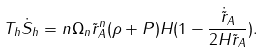Convert formula to latex. <formula><loc_0><loc_0><loc_500><loc_500>T _ { h } \dot { S } _ { h } = n \Omega _ { n } \tilde { r } _ { A } ^ { n } ( \rho + P ) H ( 1 - \frac { \dot { \tilde { r } } _ { A } } { 2 H \tilde { r } _ { A } } ) .</formula> 